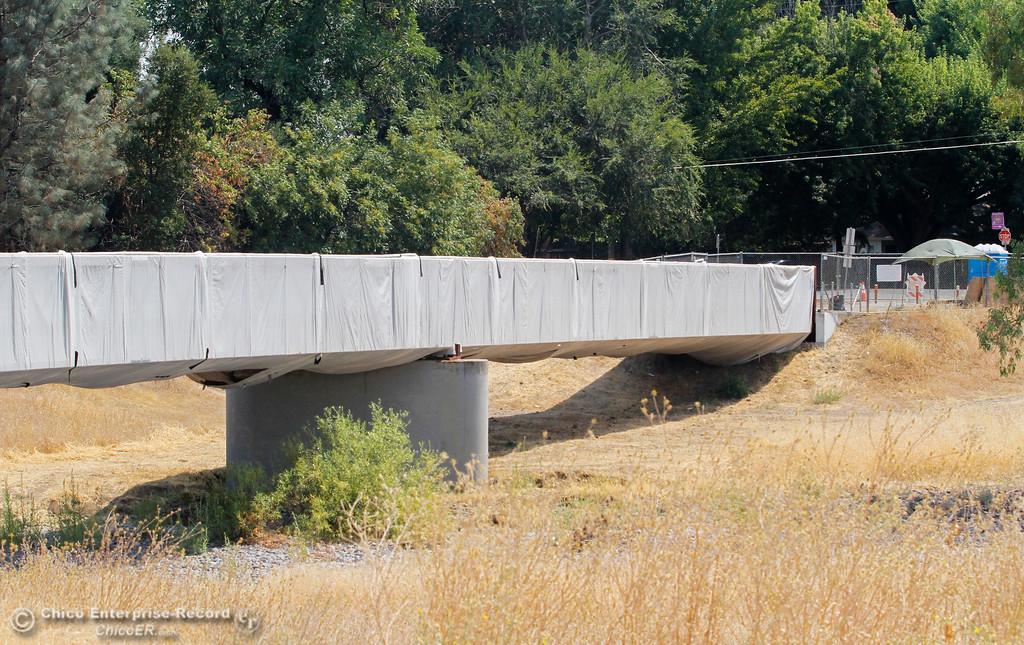Considering the white tarp covering the bridge, the fenced area with construction signs, and the presence of temporary structures, what might be the purpose of the tarp and the ongoing activities at this site? The white tarp covering the bridge, coupled with the presence of fenced areas adorned with construction signs, indicates significant maintenance, repair, or structural enhancement work being conducted. The tarp is primarily used to contain any debris, minimize environmental impacts such as dust and provide weather protection to ensure that the work can be carried out in various conditions. It may also serve as a safety measure to prevent any materials from falling outside the work zone. The temporary structures nearby likely house construction equipment and provide a base for workers for storing tools, taking breaks, and strategizing on project execution. This setup ensures that the bridge receives the necessary attention while maintaining safety standards and minimizing disruptions to the surrounding area. 